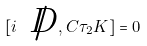<formula> <loc_0><loc_0><loc_500><loc_500>[ i \, \not { \, D } , C \tau _ { 2 } K ] = 0</formula> 